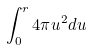Convert formula to latex. <formula><loc_0><loc_0><loc_500><loc_500>\int _ { 0 } ^ { r } 4 \pi u ^ { 2 } d u</formula> 